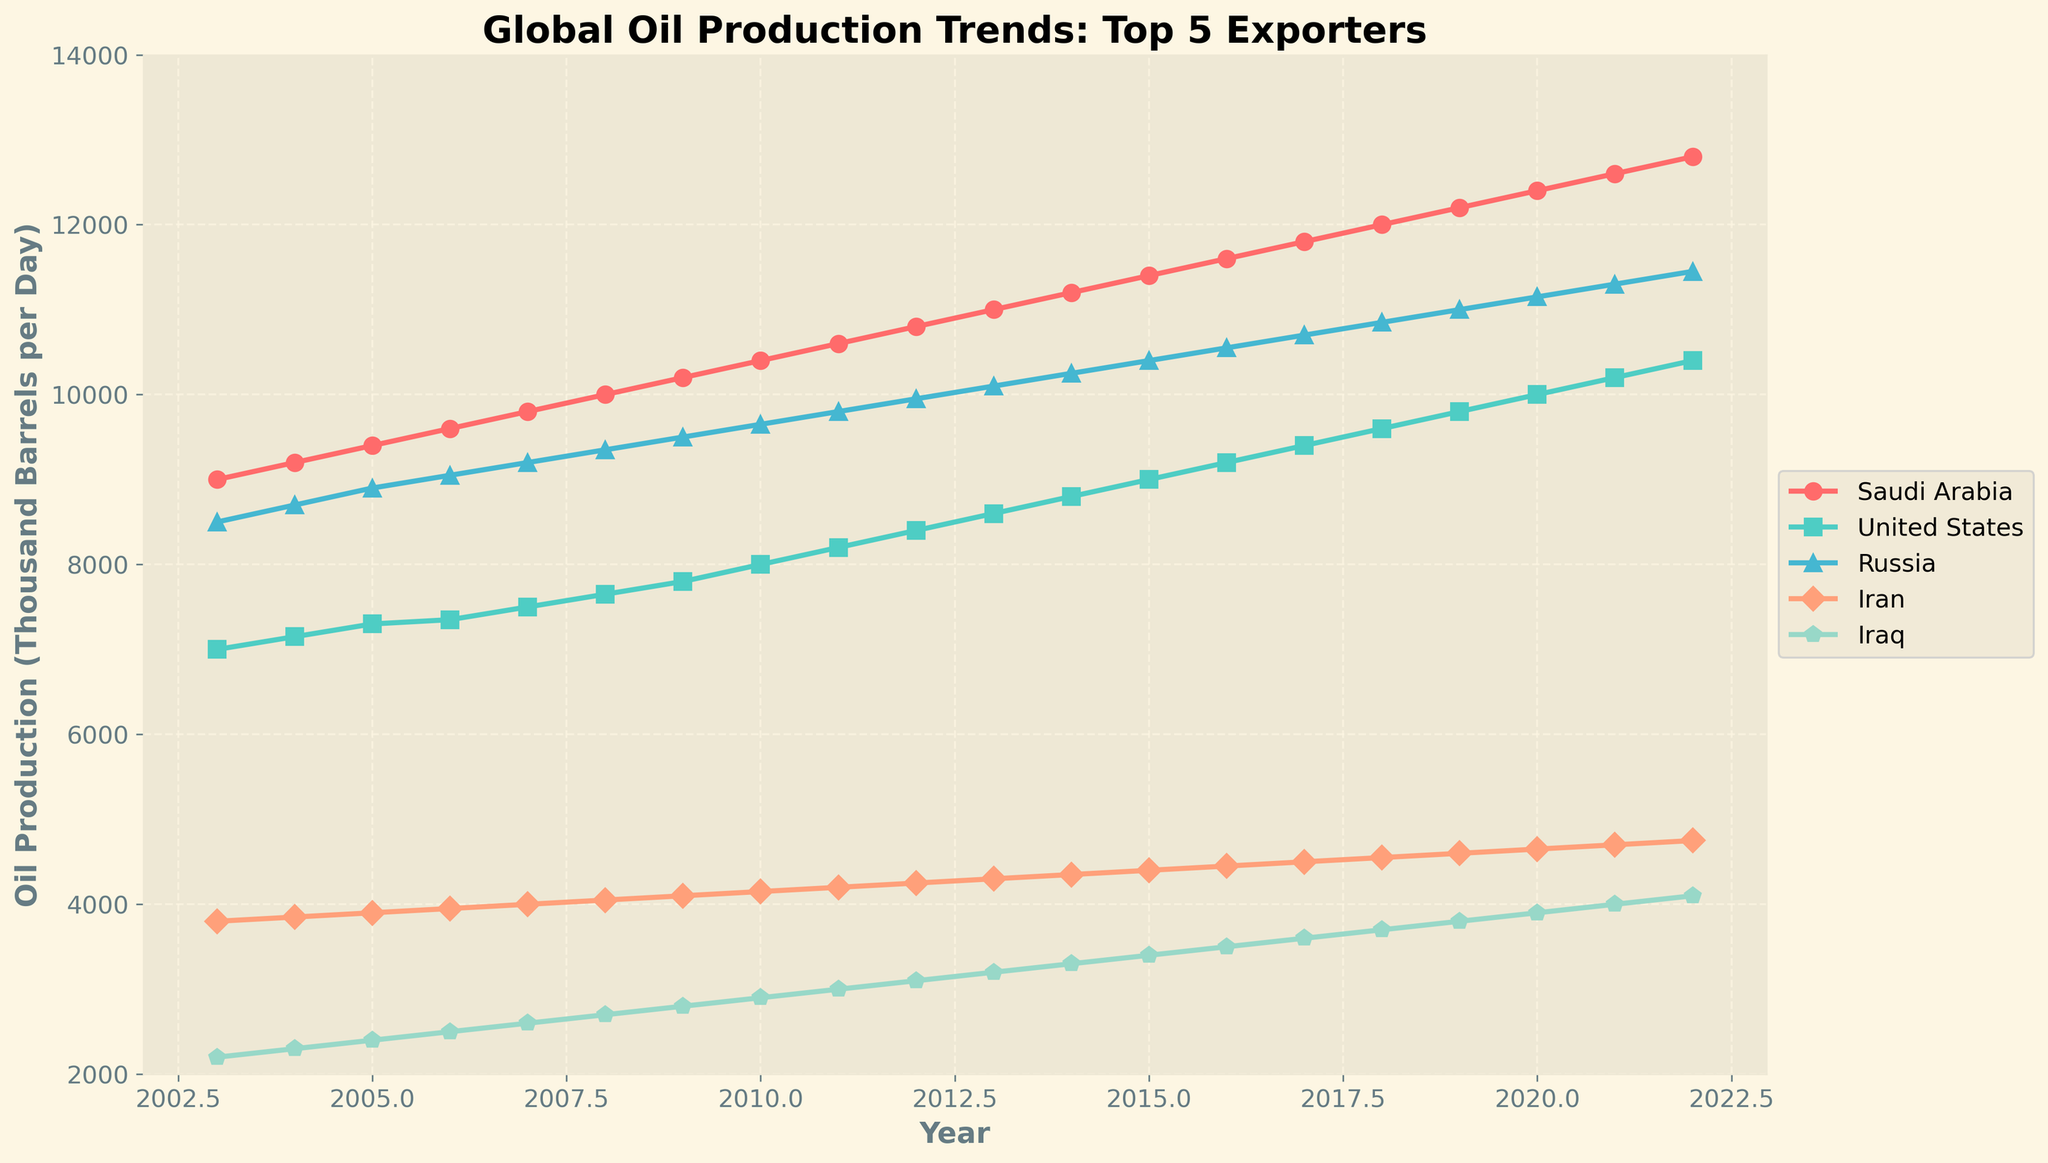What is the title of the figure? The title is usually displayed at the top of the figure. In this case, it shows "Global Oil Production Trends: Top 5 Exporters".
Answer: Global Oil Production Trends: Top 5 Exporters What is the range of years covered by the figure? The x-axis typically shows the time range. Here, the x-axis ranges from 2003 to 2022.
Answer: 2003 to 2022 Which country had the highest oil production in 2010? The highest point on the y-axis for 2010 among the displayed countries indicates the leading producer. Saudi Arabia is the highest.
Answer: Saudi Arabia How does the oil production trend of Russia compare to that of Iran from 2010 to 2022? Comparing the line trends between Russia and Iran from 2010 to 2022 on the plot, Russia shows a more pronounced increase, whereas Iran shows a more modest increase.
Answer: Russia increased more significantly than Iran What is the difference in oil production between the United States and Saudi Arabia in 2022? Locate the 2022 data points for both countries on the y-axis and subtract the U.S. production from Saudi production. Saudi Arabia: 12800, United States: 10400. Difference: 12800 - 10400
Answer: 2400 What's the average annual oil production of Iraq over the displayed period? To find the average, sum all annual production values of Iraq from 2003 to 2022 and divide by the number of years (20).
Answer: 3,050 Which country shows the most consistent growth in oil production over the displayed period? Consistent growth means a relatively smooth and steadily increasing line on the plot. The United States shows a steady and consistent upward trend.
Answer: United States Between which two consecutive years did Saudi Arabia see the highest increase in oil production? Look at the steepest increase between two consecutive data points for Saudi Arabia. The steepest increase is between 2010 (10400) and 2011 (10600).
Answer: 2010 to 2011 Which country had the least oil production in 2003? The least production ideally corresponds to the lowest point on the y-axis for 2003 among the displayed countries. Brazil had the least with 1500.
Answer: Brazil 